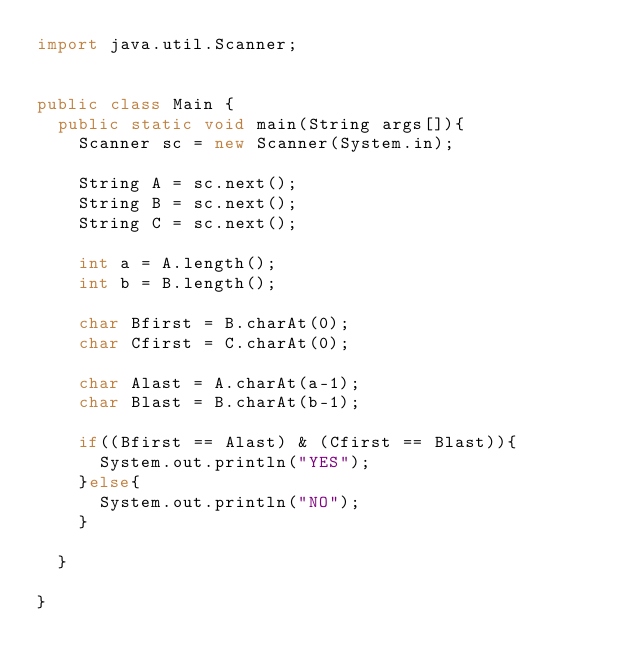<code> <loc_0><loc_0><loc_500><loc_500><_Java_>import java.util.Scanner;


public class Main {
	public static void main(String args[]){
		Scanner sc = new Scanner(System.in);
		
		String A = sc.next();
		String B = sc.next();
		String C = sc.next();
		
		int a = A.length();
		int b = B.length();
		
		char Bfirst = B.charAt(0); 
		char Cfirst = C.charAt(0);
		
		char Alast = A.charAt(a-1);
		char Blast = B.charAt(b-1);
		
		if((Bfirst == Alast) & (Cfirst == Blast)){
			System.out.println("YES");	
		}else{
			System.out.println("NO");
		}
		
	}

}</code> 